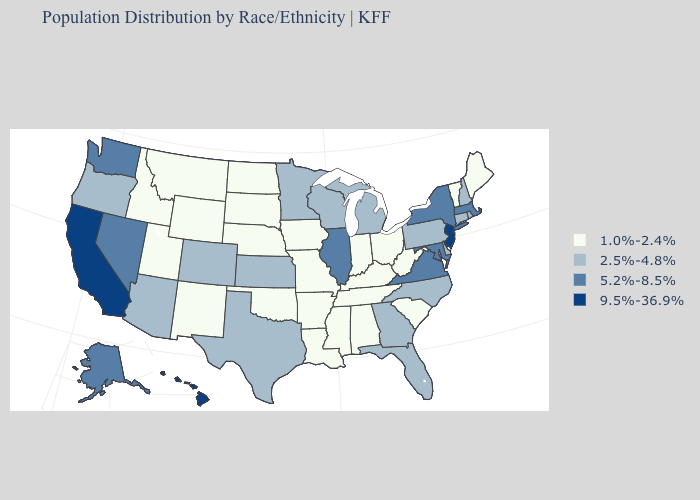Among the states that border Minnesota , does South Dakota have the highest value?
Write a very short answer. No. What is the value of Idaho?
Quick response, please. 1.0%-2.4%. Name the states that have a value in the range 1.0%-2.4%?
Give a very brief answer. Alabama, Arkansas, Idaho, Indiana, Iowa, Kentucky, Louisiana, Maine, Mississippi, Missouri, Montana, Nebraska, New Mexico, North Dakota, Ohio, Oklahoma, South Carolina, South Dakota, Tennessee, Utah, Vermont, West Virginia, Wyoming. Name the states that have a value in the range 9.5%-36.9%?
Short answer required. California, Hawaii, New Jersey. What is the value of Connecticut?
Keep it brief. 2.5%-4.8%. Name the states that have a value in the range 5.2%-8.5%?
Write a very short answer. Alaska, Illinois, Maryland, Massachusetts, Nevada, New York, Virginia, Washington. What is the lowest value in states that border New York?
Quick response, please. 1.0%-2.4%. Name the states that have a value in the range 5.2%-8.5%?
Short answer required. Alaska, Illinois, Maryland, Massachusetts, Nevada, New York, Virginia, Washington. Does Georgia have a lower value than Michigan?
Answer briefly. No. What is the highest value in states that border Louisiana?
Keep it brief. 2.5%-4.8%. Does California have the highest value in the West?
Be succinct. Yes. Does Ohio have the lowest value in the USA?
Answer briefly. Yes. Does Illinois have the highest value in the MidWest?
Write a very short answer. Yes. Name the states that have a value in the range 9.5%-36.9%?
Short answer required. California, Hawaii, New Jersey. 